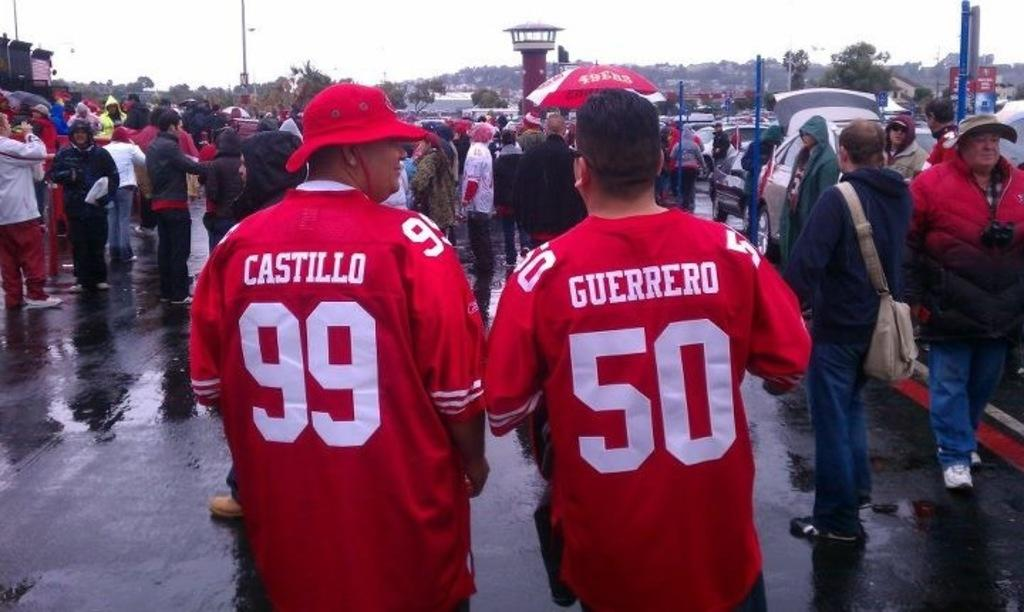Provide a one-sentence caption for the provided image. Two people wearing red sports jerseys walk with a crowd in the rain. 